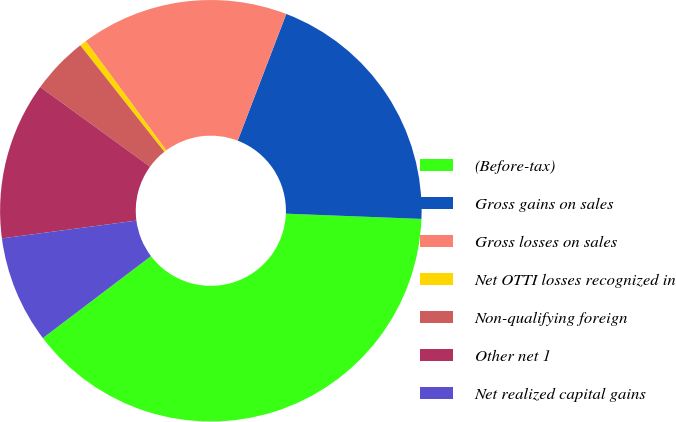Convert chart. <chart><loc_0><loc_0><loc_500><loc_500><pie_chart><fcel>(Before-tax)<fcel>Gross gains on sales<fcel>Gross losses on sales<fcel>Net OTTI losses recognized in<fcel>Non-qualifying foreign<fcel>Other net 1<fcel>Net realized capital gains<nl><fcel>39.06%<fcel>19.79%<fcel>15.94%<fcel>0.52%<fcel>4.38%<fcel>12.08%<fcel>8.23%<nl></chart> 